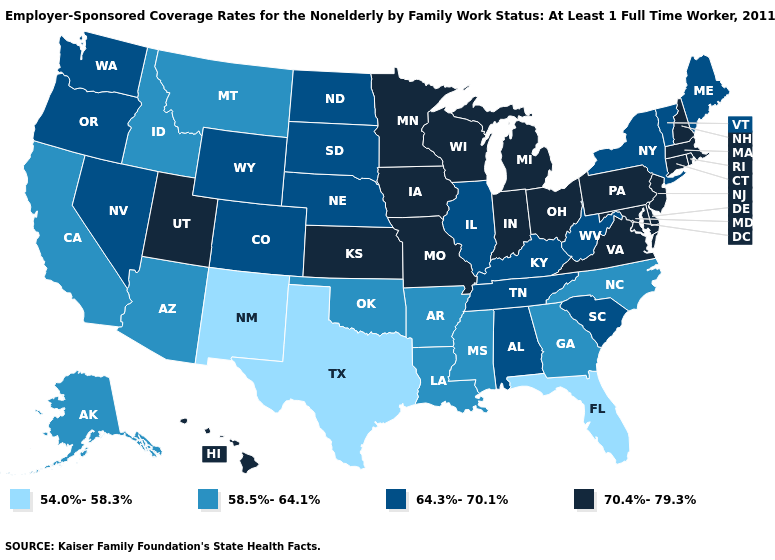Does Texas have a lower value than Maine?
Quick response, please. Yes. Which states have the lowest value in the USA?
Answer briefly. Florida, New Mexico, Texas. Which states have the lowest value in the USA?
Quick response, please. Florida, New Mexico, Texas. Does Missouri have the highest value in the USA?
Give a very brief answer. Yes. What is the lowest value in the USA?
Short answer required. 54.0%-58.3%. What is the value of Montana?
Give a very brief answer. 58.5%-64.1%. What is the lowest value in states that border Indiana?
Short answer required. 64.3%-70.1%. What is the value of Missouri?
Keep it brief. 70.4%-79.3%. Does Massachusetts have the lowest value in the USA?
Be succinct. No. What is the lowest value in the South?
Quick response, please. 54.0%-58.3%. What is the value of Vermont?
Concise answer only. 64.3%-70.1%. Which states hav the highest value in the South?
Concise answer only. Delaware, Maryland, Virginia. What is the highest value in the USA?
Short answer required. 70.4%-79.3%. What is the value of Washington?
Answer briefly. 64.3%-70.1%. 